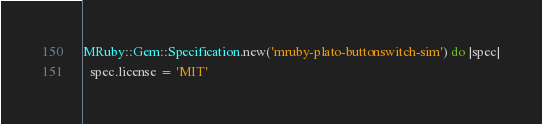<code> <loc_0><loc_0><loc_500><loc_500><_Ruby_>MRuby::Gem::Specification.new('mruby-plato-buttonswitch-sim') do |spec|
  spec.license = 'MIT'</code> 